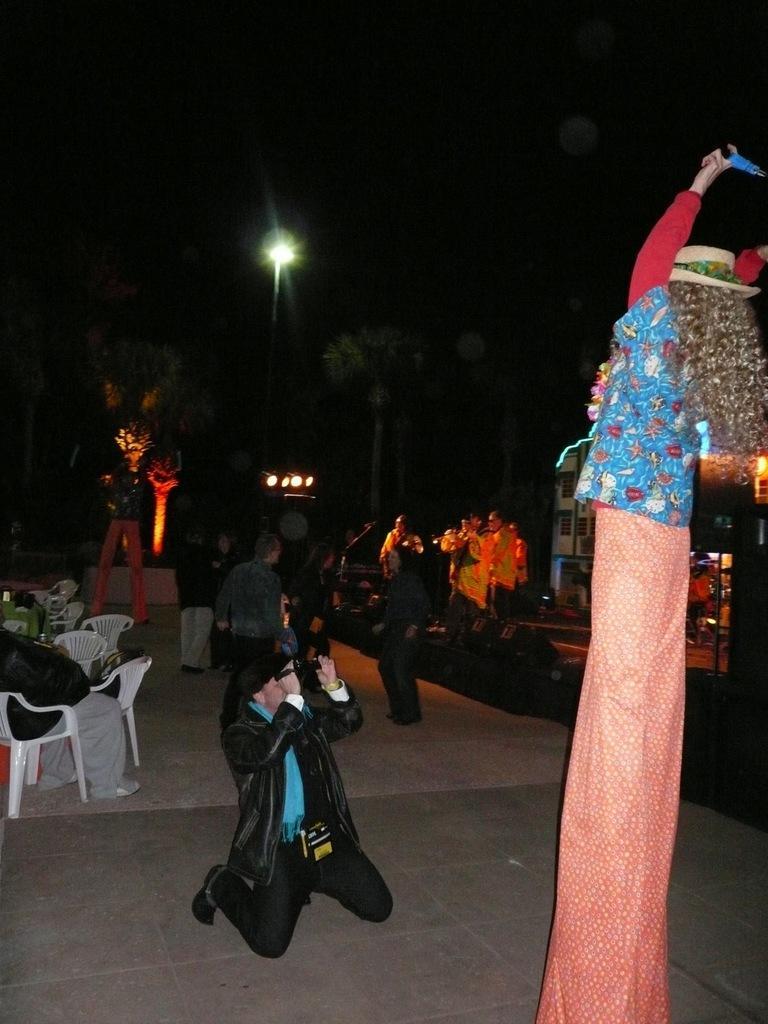Could you give a brief overview of what you see in this image? Here we can see a man who is holding a camera with his hands. These are the chairs and there are some persons standing on the road. This is tree and there is a light. 